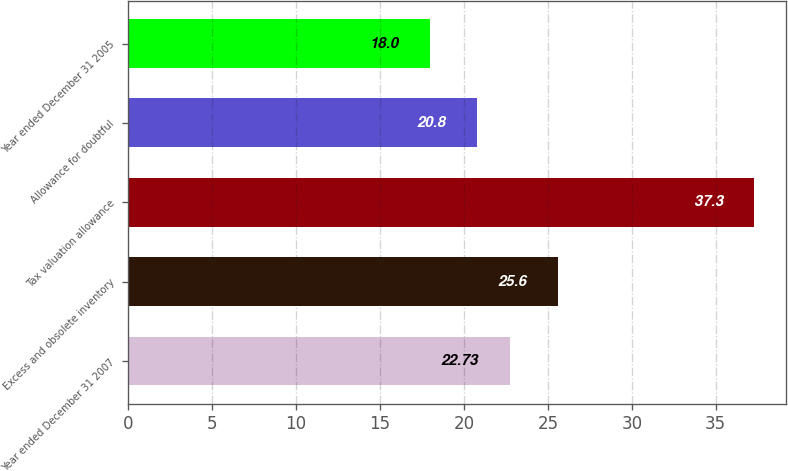<chart> <loc_0><loc_0><loc_500><loc_500><bar_chart><fcel>Year ended December 31 2007<fcel>Excess and obsolete inventory<fcel>Tax valuation allowance<fcel>Allowance for doubtful<fcel>Year ended December 31 2005<nl><fcel>22.73<fcel>25.6<fcel>37.3<fcel>20.8<fcel>18<nl></chart> 